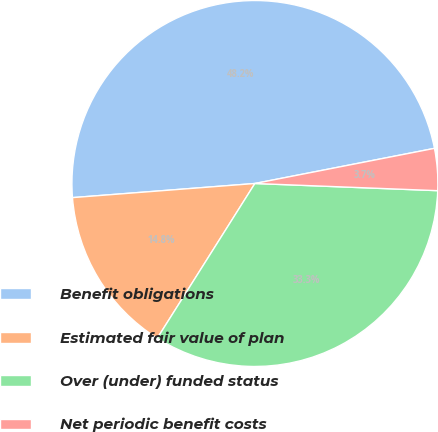Convert chart to OTSL. <chart><loc_0><loc_0><loc_500><loc_500><pie_chart><fcel>Benefit obligations<fcel>Estimated fair value of plan<fcel>Over (under) funded status<fcel>Net periodic benefit costs<nl><fcel>48.15%<fcel>14.81%<fcel>33.33%<fcel>3.7%<nl></chart> 